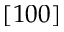<formula> <loc_0><loc_0><loc_500><loc_500>[ 1 0 0 ]</formula> 